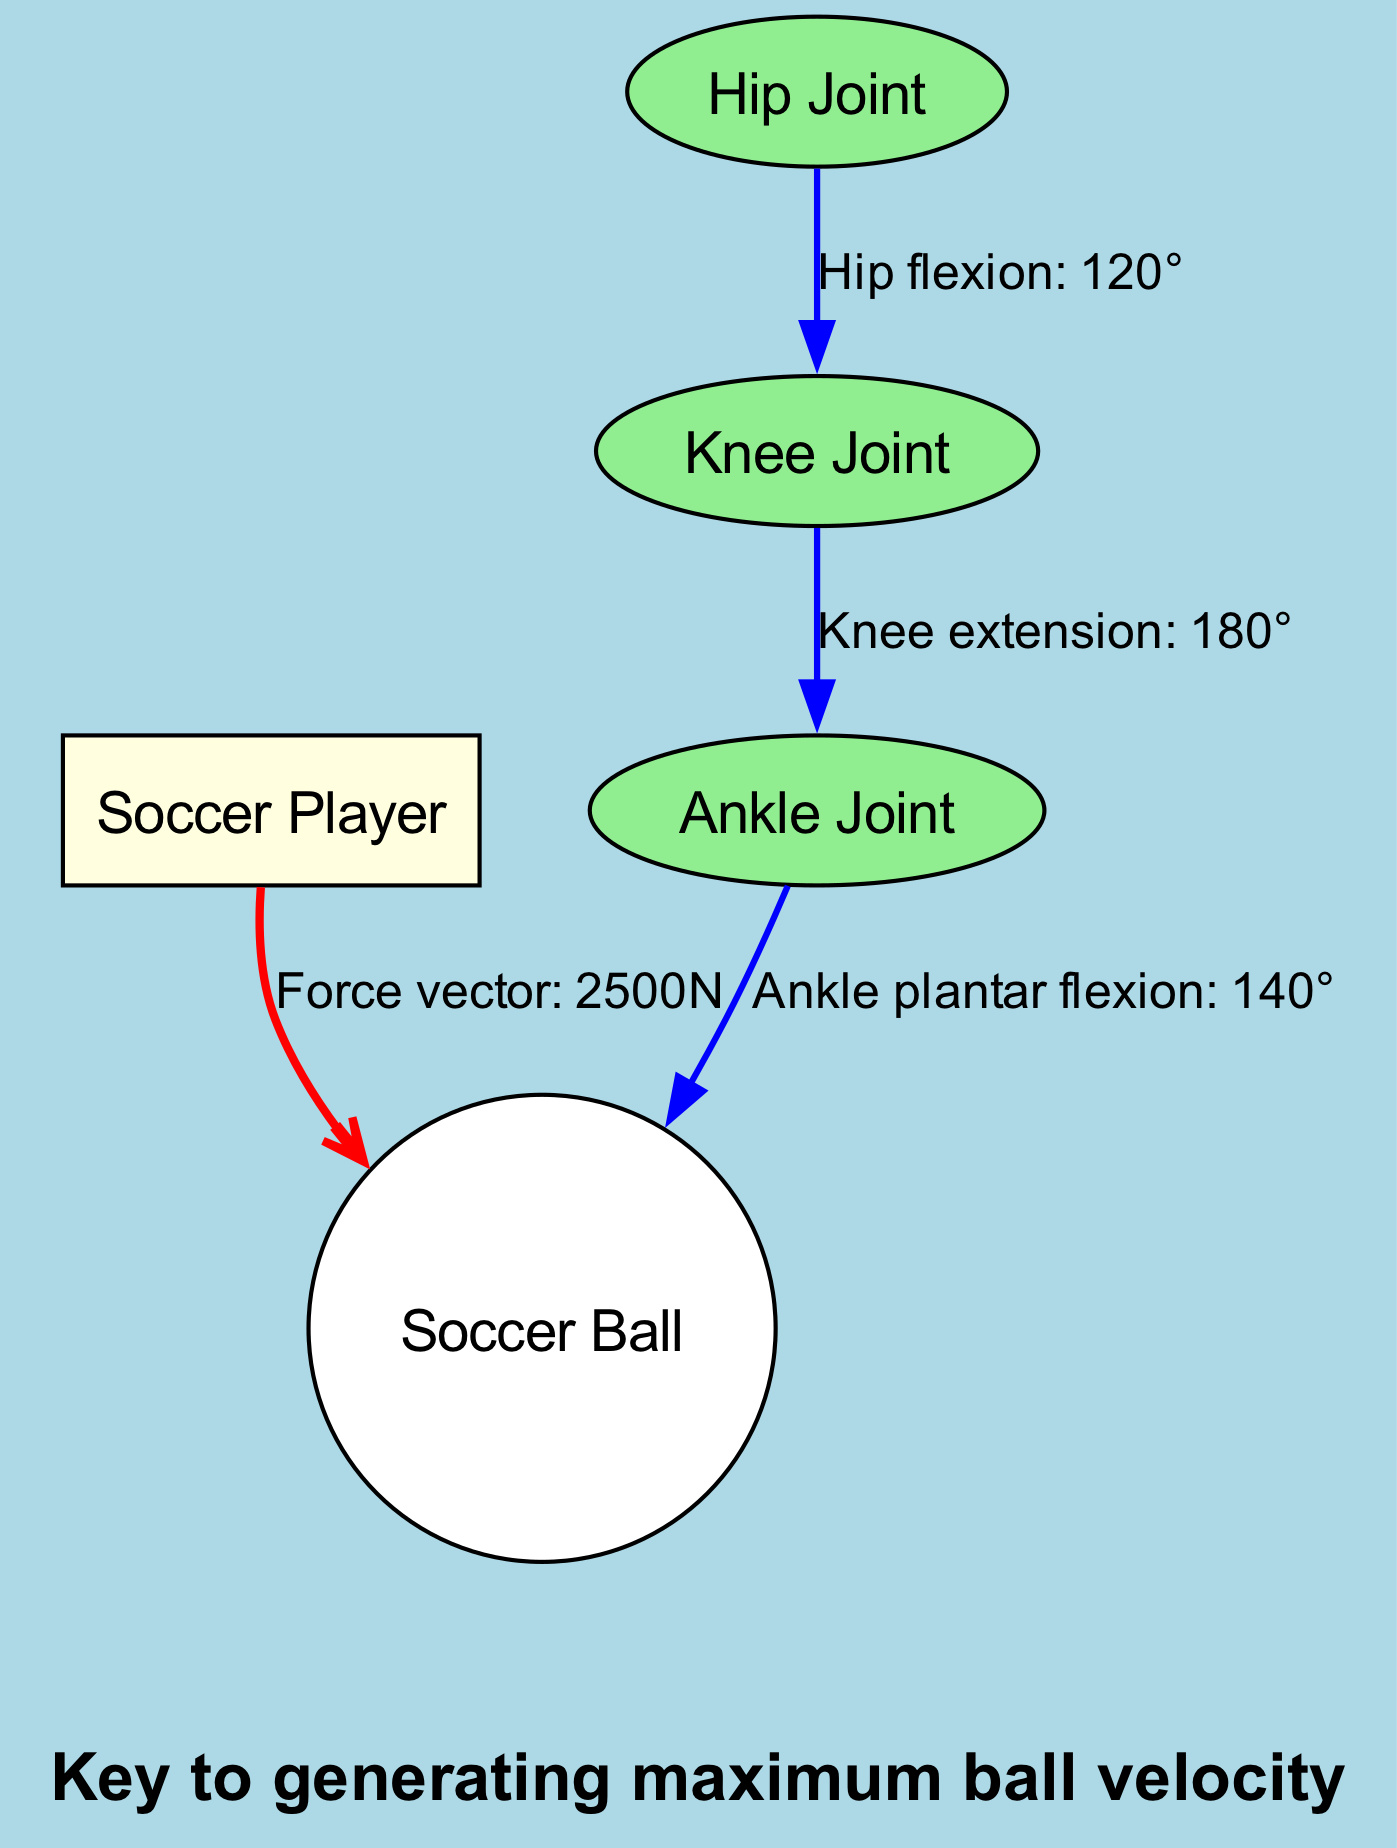What is the joint angle at the hip? The diagram specifies that the hip flexion is 120 degrees, represented by the edge from "hip" to "knee."
Answer: 120° What force is applied to the soccer ball? The edge from the "player" to the "ball" indicates a force vector of 2500N, showing the force applied during the kick.
Answer: 2500N What is the angle of knee extension? The relationship from "knee" to "ankle" shows that knee extension occurs at an angle of 180 degrees, as labeled in the diagram.
Answer: 180° How many joints are illustrated in the diagram? The nodes representing the hip, knee, and ankle joint highlight that there are three distinct joints being analyzed in the kicking motion.
Answer: 3 What does the bottom annotation indicate? The bottom annotation states "Key to generating maximum ball velocity," explaining an important aspect of the kicking technique discussed in the diagram.
Answer: Key to generating maximum ball velocity What joint angle occurs at the ankle? The diagram indicates that the ankle's position during the kick involves plantar flexion at an angle of 140 degrees, showing the specific joint motion involved.
Answer: 140° What is the relationship between hip flexion and knee extension in terms of angle? Comparing the angles, the hip flexion is 120 degrees while knee extension is 180 degrees, showing that knee extension occurs in a straightened position following hip flexion.
Answer: 120° vs 180° What is highlighted as optimal for kicking technique? The top annotation says, "Optimal kicking technique for power and accuracy," emphasizing what the diagram suggests is significant for effective kicking performance.
Answer: Optimal kicking technique for power and accuracy 